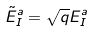<formula> <loc_0><loc_0><loc_500><loc_500>\tilde { E } _ { I } ^ { a } = \sqrt { q } E _ { I } ^ { a }</formula> 